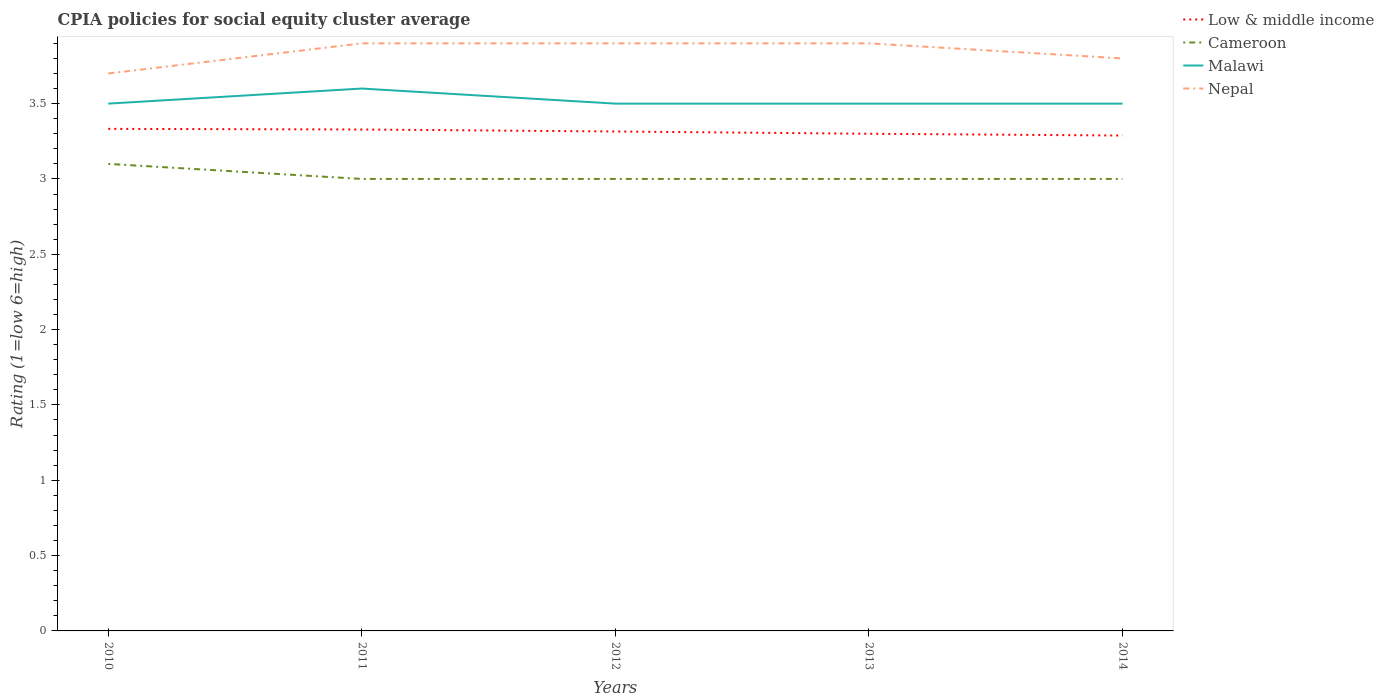Does the line corresponding to Cameroon intersect with the line corresponding to Malawi?
Ensure brevity in your answer.  No. Across all years, what is the maximum CPIA rating in Malawi?
Your answer should be very brief. 3.5. What is the difference between the highest and the second highest CPIA rating in Low & middle income?
Offer a terse response. 0.04. How many lines are there?
Provide a short and direct response. 4. How many years are there in the graph?
Keep it short and to the point. 5. Are the values on the major ticks of Y-axis written in scientific E-notation?
Your answer should be compact. No. Where does the legend appear in the graph?
Keep it short and to the point. Top right. How many legend labels are there?
Your answer should be compact. 4. What is the title of the graph?
Offer a terse response. CPIA policies for social equity cluster average. Does "Qatar" appear as one of the legend labels in the graph?
Your answer should be very brief. No. What is the label or title of the Y-axis?
Provide a succinct answer. Rating (1=low 6=high). What is the Rating (1=low 6=high) in Low & middle income in 2010?
Ensure brevity in your answer.  3.33. What is the Rating (1=low 6=high) in Cameroon in 2010?
Make the answer very short. 3.1. What is the Rating (1=low 6=high) in Malawi in 2010?
Make the answer very short. 3.5. What is the Rating (1=low 6=high) of Low & middle income in 2011?
Keep it short and to the point. 3.33. What is the Rating (1=low 6=high) of Cameroon in 2011?
Provide a succinct answer. 3. What is the Rating (1=low 6=high) in Low & middle income in 2012?
Make the answer very short. 3.31. What is the Rating (1=low 6=high) in Cameroon in 2012?
Keep it short and to the point. 3. What is the Rating (1=low 6=high) in Nepal in 2012?
Offer a terse response. 3.9. What is the Rating (1=low 6=high) in Cameroon in 2013?
Your answer should be compact. 3. What is the Rating (1=low 6=high) of Low & middle income in 2014?
Offer a terse response. 3.29. What is the Rating (1=low 6=high) of Malawi in 2014?
Make the answer very short. 3.5. Across all years, what is the maximum Rating (1=low 6=high) in Low & middle income?
Provide a short and direct response. 3.33. Across all years, what is the maximum Rating (1=low 6=high) of Malawi?
Give a very brief answer. 3.6. Across all years, what is the maximum Rating (1=low 6=high) in Nepal?
Give a very brief answer. 3.9. Across all years, what is the minimum Rating (1=low 6=high) of Low & middle income?
Keep it short and to the point. 3.29. Across all years, what is the minimum Rating (1=low 6=high) in Cameroon?
Offer a very short reply. 3. What is the total Rating (1=low 6=high) of Low & middle income in the graph?
Provide a succinct answer. 16.56. What is the total Rating (1=low 6=high) of Cameroon in the graph?
Offer a terse response. 15.1. What is the difference between the Rating (1=low 6=high) in Low & middle income in 2010 and that in 2011?
Keep it short and to the point. 0. What is the difference between the Rating (1=low 6=high) in Cameroon in 2010 and that in 2011?
Offer a terse response. 0.1. What is the difference between the Rating (1=low 6=high) of Malawi in 2010 and that in 2011?
Give a very brief answer. -0.1. What is the difference between the Rating (1=low 6=high) in Nepal in 2010 and that in 2011?
Your answer should be compact. -0.2. What is the difference between the Rating (1=low 6=high) of Low & middle income in 2010 and that in 2012?
Your answer should be very brief. 0.02. What is the difference between the Rating (1=low 6=high) in Cameroon in 2010 and that in 2012?
Keep it short and to the point. 0.1. What is the difference between the Rating (1=low 6=high) of Low & middle income in 2010 and that in 2013?
Offer a terse response. 0.03. What is the difference between the Rating (1=low 6=high) of Nepal in 2010 and that in 2013?
Ensure brevity in your answer.  -0.2. What is the difference between the Rating (1=low 6=high) of Low & middle income in 2010 and that in 2014?
Your answer should be compact. 0.04. What is the difference between the Rating (1=low 6=high) in Cameroon in 2010 and that in 2014?
Offer a very short reply. 0.1. What is the difference between the Rating (1=low 6=high) of Nepal in 2010 and that in 2014?
Ensure brevity in your answer.  -0.1. What is the difference between the Rating (1=low 6=high) in Low & middle income in 2011 and that in 2012?
Provide a succinct answer. 0.01. What is the difference between the Rating (1=low 6=high) of Cameroon in 2011 and that in 2012?
Provide a succinct answer. 0. What is the difference between the Rating (1=low 6=high) in Nepal in 2011 and that in 2012?
Provide a succinct answer. 0. What is the difference between the Rating (1=low 6=high) in Low & middle income in 2011 and that in 2013?
Make the answer very short. 0.03. What is the difference between the Rating (1=low 6=high) in Cameroon in 2011 and that in 2013?
Your answer should be compact. 0. What is the difference between the Rating (1=low 6=high) in Nepal in 2011 and that in 2013?
Offer a very short reply. 0. What is the difference between the Rating (1=low 6=high) in Low & middle income in 2011 and that in 2014?
Your answer should be very brief. 0.04. What is the difference between the Rating (1=low 6=high) of Cameroon in 2011 and that in 2014?
Offer a very short reply. 0. What is the difference between the Rating (1=low 6=high) in Malawi in 2011 and that in 2014?
Your response must be concise. 0.1. What is the difference between the Rating (1=low 6=high) in Low & middle income in 2012 and that in 2013?
Your answer should be very brief. 0.01. What is the difference between the Rating (1=low 6=high) in Malawi in 2012 and that in 2013?
Ensure brevity in your answer.  0. What is the difference between the Rating (1=low 6=high) of Nepal in 2012 and that in 2013?
Make the answer very short. 0. What is the difference between the Rating (1=low 6=high) in Low & middle income in 2012 and that in 2014?
Give a very brief answer. 0.03. What is the difference between the Rating (1=low 6=high) of Low & middle income in 2013 and that in 2014?
Provide a short and direct response. 0.01. What is the difference between the Rating (1=low 6=high) in Cameroon in 2013 and that in 2014?
Your answer should be very brief. 0. What is the difference between the Rating (1=low 6=high) of Malawi in 2013 and that in 2014?
Offer a terse response. 0. What is the difference between the Rating (1=low 6=high) of Low & middle income in 2010 and the Rating (1=low 6=high) of Cameroon in 2011?
Your response must be concise. 0.33. What is the difference between the Rating (1=low 6=high) of Low & middle income in 2010 and the Rating (1=low 6=high) of Malawi in 2011?
Give a very brief answer. -0.27. What is the difference between the Rating (1=low 6=high) in Low & middle income in 2010 and the Rating (1=low 6=high) in Nepal in 2011?
Your answer should be compact. -0.57. What is the difference between the Rating (1=low 6=high) in Cameroon in 2010 and the Rating (1=low 6=high) in Malawi in 2011?
Offer a terse response. -0.5. What is the difference between the Rating (1=low 6=high) of Low & middle income in 2010 and the Rating (1=low 6=high) of Cameroon in 2012?
Your answer should be compact. 0.33. What is the difference between the Rating (1=low 6=high) in Low & middle income in 2010 and the Rating (1=low 6=high) in Malawi in 2012?
Give a very brief answer. -0.17. What is the difference between the Rating (1=low 6=high) in Low & middle income in 2010 and the Rating (1=low 6=high) in Nepal in 2012?
Keep it short and to the point. -0.57. What is the difference between the Rating (1=low 6=high) of Cameroon in 2010 and the Rating (1=low 6=high) of Malawi in 2012?
Your answer should be very brief. -0.4. What is the difference between the Rating (1=low 6=high) of Malawi in 2010 and the Rating (1=low 6=high) of Nepal in 2012?
Your answer should be very brief. -0.4. What is the difference between the Rating (1=low 6=high) of Low & middle income in 2010 and the Rating (1=low 6=high) of Cameroon in 2013?
Make the answer very short. 0.33. What is the difference between the Rating (1=low 6=high) of Low & middle income in 2010 and the Rating (1=low 6=high) of Malawi in 2013?
Your response must be concise. -0.17. What is the difference between the Rating (1=low 6=high) in Low & middle income in 2010 and the Rating (1=low 6=high) in Nepal in 2013?
Offer a very short reply. -0.57. What is the difference between the Rating (1=low 6=high) of Low & middle income in 2010 and the Rating (1=low 6=high) of Cameroon in 2014?
Provide a short and direct response. 0.33. What is the difference between the Rating (1=low 6=high) of Low & middle income in 2010 and the Rating (1=low 6=high) of Malawi in 2014?
Provide a short and direct response. -0.17. What is the difference between the Rating (1=low 6=high) in Low & middle income in 2010 and the Rating (1=low 6=high) in Nepal in 2014?
Provide a succinct answer. -0.47. What is the difference between the Rating (1=low 6=high) in Malawi in 2010 and the Rating (1=low 6=high) in Nepal in 2014?
Provide a short and direct response. -0.3. What is the difference between the Rating (1=low 6=high) of Low & middle income in 2011 and the Rating (1=low 6=high) of Cameroon in 2012?
Your answer should be very brief. 0.33. What is the difference between the Rating (1=low 6=high) of Low & middle income in 2011 and the Rating (1=low 6=high) of Malawi in 2012?
Your answer should be very brief. -0.17. What is the difference between the Rating (1=low 6=high) of Low & middle income in 2011 and the Rating (1=low 6=high) of Nepal in 2012?
Ensure brevity in your answer.  -0.57. What is the difference between the Rating (1=low 6=high) in Cameroon in 2011 and the Rating (1=low 6=high) in Malawi in 2012?
Offer a very short reply. -0.5. What is the difference between the Rating (1=low 6=high) of Cameroon in 2011 and the Rating (1=low 6=high) of Nepal in 2012?
Your answer should be compact. -0.9. What is the difference between the Rating (1=low 6=high) of Low & middle income in 2011 and the Rating (1=low 6=high) of Cameroon in 2013?
Your response must be concise. 0.33. What is the difference between the Rating (1=low 6=high) of Low & middle income in 2011 and the Rating (1=low 6=high) of Malawi in 2013?
Provide a short and direct response. -0.17. What is the difference between the Rating (1=low 6=high) of Low & middle income in 2011 and the Rating (1=low 6=high) of Nepal in 2013?
Provide a short and direct response. -0.57. What is the difference between the Rating (1=low 6=high) of Malawi in 2011 and the Rating (1=low 6=high) of Nepal in 2013?
Make the answer very short. -0.3. What is the difference between the Rating (1=low 6=high) in Low & middle income in 2011 and the Rating (1=low 6=high) in Cameroon in 2014?
Keep it short and to the point. 0.33. What is the difference between the Rating (1=low 6=high) of Low & middle income in 2011 and the Rating (1=low 6=high) of Malawi in 2014?
Provide a succinct answer. -0.17. What is the difference between the Rating (1=low 6=high) of Low & middle income in 2011 and the Rating (1=low 6=high) of Nepal in 2014?
Provide a short and direct response. -0.47. What is the difference between the Rating (1=low 6=high) in Cameroon in 2011 and the Rating (1=low 6=high) in Malawi in 2014?
Your answer should be compact. -0.5. What is the difference between the Rating (1=low 6=high) in Low & middle income in 2012 and the Rating (1=low 6=high) in Cameroon in 2013?
Give a very brief answer. 0.32. What is the difference between the Rating (1=low 6=high) of Low & middle income in 2012 and the Rating (1=low 6=high) of Malawi in 2013?
Ensure brevity in your answer.  -0.18. What is the difference between the Rating (1=low 6=high) in Low & middle income in 2012 and the Rating (1=low 6=high) in Nepal in 2013?
Ensure brevity in your answer.  -0.58. What is the difference between the Rating (1=low 6=high) in Malawi in 2012 and the Rating (1=low 6=high) in Nepal in 2013?
Offer a terse response. -0.4. What is the difference between the Rating (1=low 6=high) of Low & middle income in 2012 and the Rating (1=low 6=high) of Cameroon in 2014?
Make the answer very short. 0.32. What is the difference between the Rating (1=low 6=high) in Low & middle income in 2012 and the Rating (1=low 6=high) in Malawi in 2014?
Provide a succinct answer. -0.18. What is the difference between the Rating (1=low 6=high) of Low & middle income in 2012 and the Rating (1=low 6=high) of Nepal in 2014?
Ensure brevity in your answer.  -0.48. What is the difference between the Rating (1=low 6=high) of Cameroon in 2012 and the Rating (1=low 6=high) of Nepal in 2014?
Keep it short and to the point. -0.8. What is the difference between the Rating (1=low 6=high) of Malawi in 2012 and the Rating (1=low 6=high) of Nepal in 2014?
Provide a short and direct response. -0.3. What is the difference between the Rating (1=low 6=high) of Low & middle income in 2013 and the Rating (1=low 6=high) of Malawi in 2014?
Ensure brevity in your answer.  -0.2. What is the difference between the Rating (1=low 6=high) in Low & middle income in 2013 and the Rating (1=low 6=high) in Nepal in 2014?
Keep it short and to the point. -0.5. What is the difference between the Rating (1=low 6=high) in Cameroon in 2013 and the Rating (1=low 6=high) in Malawi in 2014?
Offer a very short reply. -0.5. What is the difference between the Rating (1=low 6=high) of Malawi in 2013 and the Rating (1=low 6=high) of Nepal in 2014?
Offer a terse response. -0.3. What is the average Rating (1=low 6=high) of Low & middle income per year?
Give a very brief answer. 3.31. What is the average Rating (1=low 6=high) of Cameroon per year?
Ensure brevity in your answer.  3.02. What is the average Rating (1=low 6=high) of Malawi per year?
Keep it short and to the point. 3.52. What is the average Rating (1=low 6=high) of Nepal per year?
Your answer should be compact. 3.84. In the year 2010, what is the difference between the Rating (1=low 6=high) in Low & middle income and Rating (1=low 6=high) in Cameroon?
Give a very brief answer. 0.23. In the year 2010, what is the difference between the Rating (1=low 6=high) of Low & middle income and Rating (1=low 6=high) of Malawi?
Give a very brief answer. -0.17. In the year 2010, what is the difference between the Rating (1=low 6=high) of Low & middle income and Rating (1=low 6=high) of Nepal?
Provide a succinct answer. -0.37. In the year 2010, what is the difference between the Rating (1=low 6=high) in Cameroon and Rating (1=low 6=high) in Nepal?
Your answer should be very brief. -0.6. In the year 2011, what is the difference between the Rating (1=low 6=high) in Low & middle income and Rating (1=low 6=high) in Cameroon?
Ensure brevity in your answer.  0.33. In the year 2011, what is the difference between the Rating (1=low 6=high) of Low & middle income and Rating (1=low 6=high) of Malawi?
Offer a terse response. -0.27. In the year 2011, what is the difference between the Rating (1=low 6=high) in Low & middle income and Rating (1=low 6=high) in Nepal?
Make the answer very short. -0.57. In the year 2011, what is the difference between the Rating (1=low 6=high) of Cameroon and Rating (1=low 6=high) of Nepal?
Make the answer very short. -0.9. In the year 2011, what is the difference between the Rating (1=low 6=high) in Malawi and Rating (1=low 6=high) in Nepal?
Offer a terse response. -0.3. In the year 2012, what is the difference between the Rating (1=low 6=high) of Low & middle income and Rating (1=low 6=high) of Cameroon?
Keep it short and to the point. 0.32. In the year 2012, what is the difference between the Rating (1=low 6=high) in Low & middle income and Rating (1=low 6=high) in Malawi?
Your answer should be very brief. -0.18. In the year 2012, what is the difference between the Rating (1=low 6=high) of Low & middle income and Rating (1=low 6=high) of Nepal?
Provide a succinct answer. -0.58. In the year 2012, what is the difference between the Rating (1=low 6=high) in Malawi and Rating (1=low 6=high) in Nepal?
Your response must be concise. -0.4. In the year 2013, what is the difference between the Rating (1=low 6=high) in Low & middle income and Rating (1=low 6=high) in Cameroon?
Keep it short and to the point. 0.3. In the year 2013, what is the difference between the Rating (1=low 6=high) in Low & middle income and Rating (1=low 6=high) in Nepal?
Give a very brief answer. -0.6. In the year 2013, what is the difference between the Rating (1=low 6=high) of Cameroon and Rating (1=low 6=high) of Malawi?
Offer a very short reply. -0.5. In the year 2014, what is the difference between the Rating (1=low 6=high) in Low & middle income and Rating (1=low 6=high) in Cameroon?
Keep it short and to the point. 0.29. In the year 2014, what is the difference between the Rating (1=low 6=high) of Low & middle income and Rating (1=low 6=high) of Malawi?
Offer a very short reply. -0.21. In the year 2014, what is the difference between the Rating (1=low 6=high) of Low & middle income and Rating (1=low 6=high) of Nepal?
Your answer should be very brief. -0.51. What is the ratio of the Rating (1=low 6=high) in Malawi in 2010 to that in 2011?
Ensure brevity in your answer.  0.97. What is the ratio of the Rating (1=low 6=high) of Nepal in 2010 to that in 2011?
Offer a very short reply. 0.95. What is the ratio of the Rating (1=low 6=high) of Nepal in 2010 to that in 2012?
Provide a short and direct response. 0.95. What is the ratio of the Rating (1=low 6=high) in Low & middle income in 2010 to that in 2013?
Offer a terse response. 1.01. What is the ratio of the Rating (1=low 6=high) of Nepal in 2010 to that in 2013?
Your response must be concise. 0.95. What is the ratio of the Rating (1=low 6=high) in Low & middle income in 2010 to that in 2014?
Give a very brief answer. 1.01. What is the ratio of the Rating (1=low 6=high) of Nepal in 2010 to that in 2014?
Your answer should be very brief. 0.97. What is the ratio of the Rating (1=low 6=high) of Low & middle income in 2011 to that in 2012?
Make the answer very short. 1. What is the ratio of the Rating (1=low 6=high) of Malawi in 2011 to that in 2012?
Provide a succinct answer. 1.03. What is the ratio of the Rating (1=low 6=high) of Low & middle income in 2011 to that in 2013?
Ensure brevity in your answer.  1.01. What is the ratio of the Rating (1=low 6=high) of Malawi in 2011 to that in 2013?
Offer a very short reply. 1.03. What is the ratio of the Rating (1=low 6=high) in Low & middle income in 2011 to that in 2014?
Your answer should be very brief. 1.01. What is the ratio of the Rating (1=low 6=high) of Malawi in 2011 to that in 2014?
Your answer should be very brief. 1.03. What is the ratio of the Rating (1=low 6=high) in Nepal in 2011 to that in 2014?
Offer a very short reply. 1.03. What is the ratio of the Rating (1=low 6=high) in Low & middle income in 2012 to that in 2013?
Give a very brief answer. 1. What is the ratio of the Rating (1=low 6=high) of Low & middle income in 2012 to that in 2014?
Keep it short and to the point. 1.01. What is the ratio of the Rating (1=low 6=high) in Cameroon in 2012 to that in 2014?
Your response must be concise. 1. What is the ratio of the Rating (1=low 6=high) in Malawi in 2012 to that in 2014?
Provide a short and direct response. 1. What is the ratio of the Rating (1=low 6=high) in Nepal in 2012 to that in 2014?
Offer a very short reply. 1.03. What is the ratio of the Rating (1=low 6=high) of Cameroon in 2013 to that in 2014?
Ensure brevity in your answer.  1. What is the ratio of the Rating (1=low 6=high) of Malawi in 2013 to that in 2014?
Offer a very short reply. 1. What is the ratio of the Rating (1=low 6=high) of Nepal in 2013 to that in 2014?
Your answer should be very brief. 1.03. What is the difference between the highest and the second highest Rating (1=low 6=high) in Low & middle income?
Your answer should be compact. 0. What is the difference between the highest and the second highest Rating (1=low 6=high) of Malawi?
Offer a terse response. 0.1. What is the difference between the highest and the second highest Rating (1=low 6=high) in Nepal?
Give a very brief answer. 0. What is the difference between the highest and the lowest Rating (1=low 6=high) in Low & middle income?
Make the answer very short. 0.04. What is the difference between the highest and the lowest Rating (1=low 6=high) in Cameroon?
Your answer should be very brief. 0.1. What is the difference between the highest and the lowest Rating (1=low 6=high) of Malawi?
Keep it short and to the point. 0.1. 